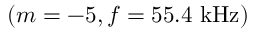Convert formula to latex. <formula><loc_0><loc_0><loc_500><loc_500>( m = - 5 , f = 5 5 . 4 k H z )</formula> 